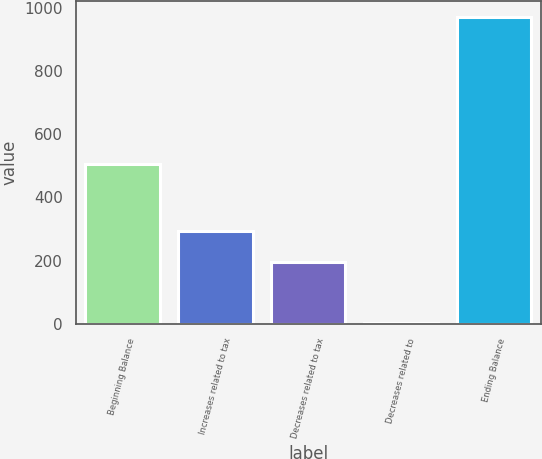Convert chart to OTSL. <chart><loc_0><loc_0><loc_500><loc_500><bar_chart><fcel>Beginning Balance<fcel>Increases related to tax<fcel>Decreases related to tax<fcel>Decreases related to<fcel>Ending Balance<nl><fcel>506<fcel>293.4<fcel>196.6<fcel>3<fcel>971<nl></chart> 